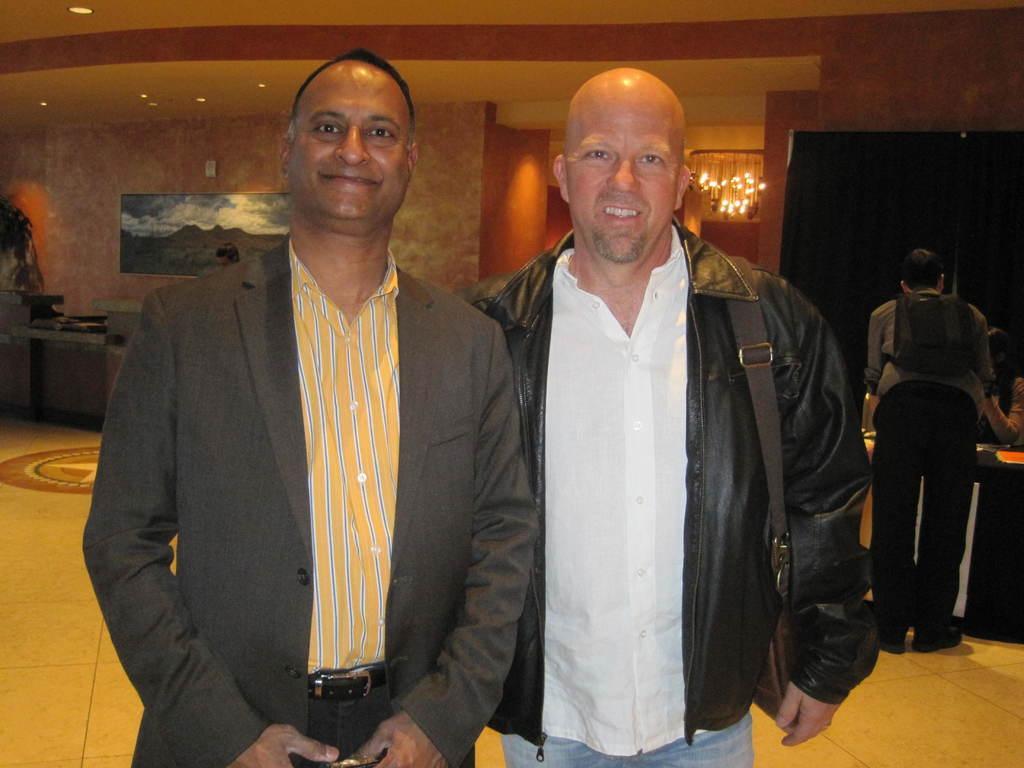Can you describe this image briefly? In this picture we can see two men are standing and smiling, a man on the right side is carrying a bag, in the background there is a chandelier, a wall and a screen, on the right side we can see another person. 